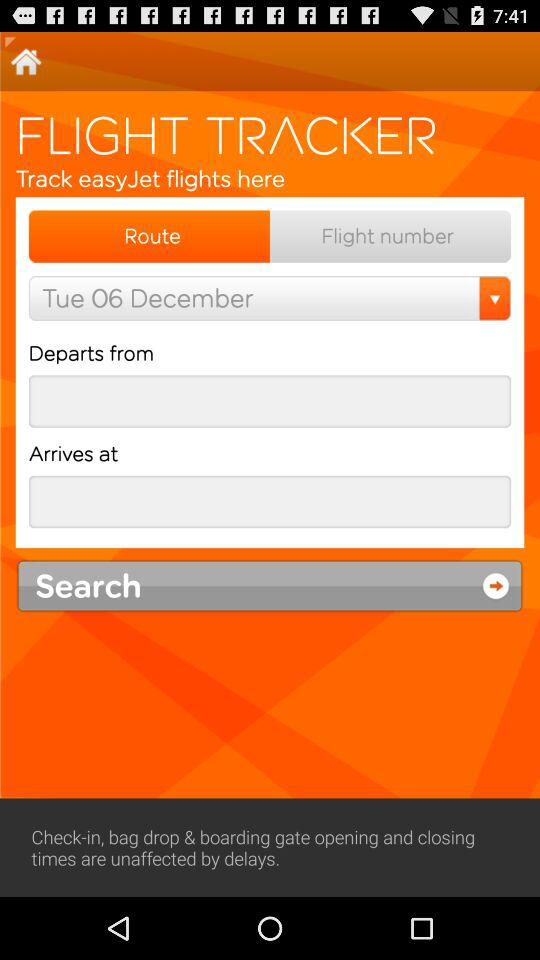What is the selected date? The selected date is Tuesday, December 6. 